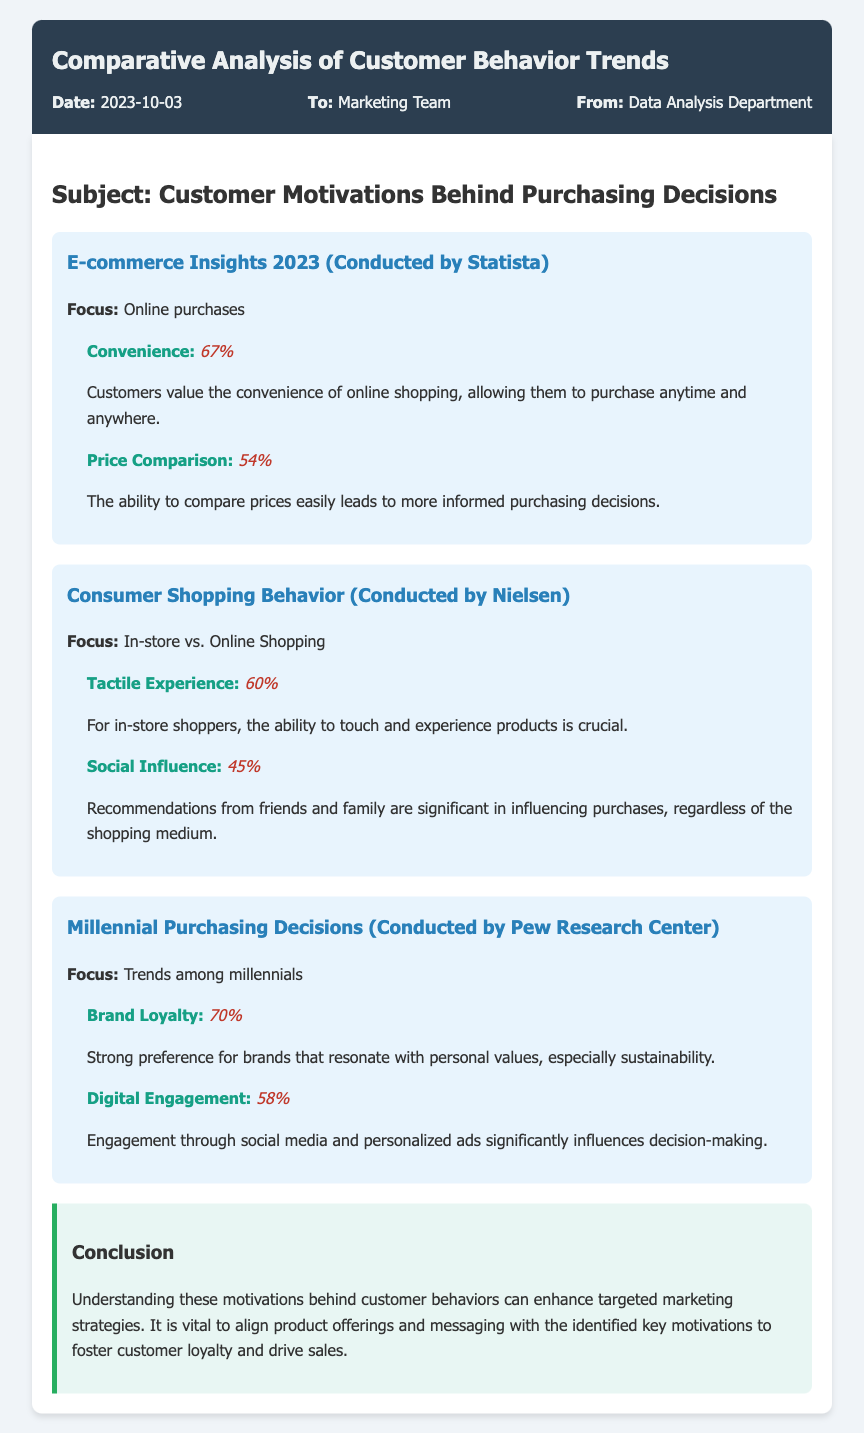what is the date of the memo? The date of the memo is mentioned in the memo info section, which states the date as 2023-10-03.
Answer: 2023-10-03 who conducted the survey for the e-commerce insights? The survey for the e-commerce insights was conducted by Statista, as stated in the survey section.
Answer: Statista what percentage of customers value convenience in online shopping? The percentage of customers who value convenience in online shopping is provided in the survey section, which states 67%.
Answer: 67% which factor influences purchasing decisions among millennials the most? The factor with the highest percentage of influence on millennials' purchasing decisions is stated in the survey as brand loyalty at 70%.
Answer: Brand Loyalty what type of shopping experience is preferred by 60% of in-store shoppers? The document mentions that 60% of in-store shoppers prefer the tactile experience, which involves touching and experiencing products.
Answer: Tactile Experience how does social influence affect purchasing decisions according to the survey? The survey indicates that social influence significantly affects purchasing decisions, as demonstrated by the 45% of customers influenced by recommendations from friends and family.
Answer: 45% what is the main focus of the survey conducted by Pew Research Center? The main focus of the Pew Research Center survey is stated as millennials' purchasing decisions and trends among them.
Answer: Trends among millennials what do customers prefer when it comes to brand values? The memo indicates that customers have a strong preference for brands that resonate with personal values, particularly sustainability.
Answer: Sustainability what do the conclusion suggest for targeted marketing strategies? The conclusion suggests aligning product offerings and messaging with the identified motivations to enhance targeted marketing strategies.
Answer: Align product offerings and messaging 